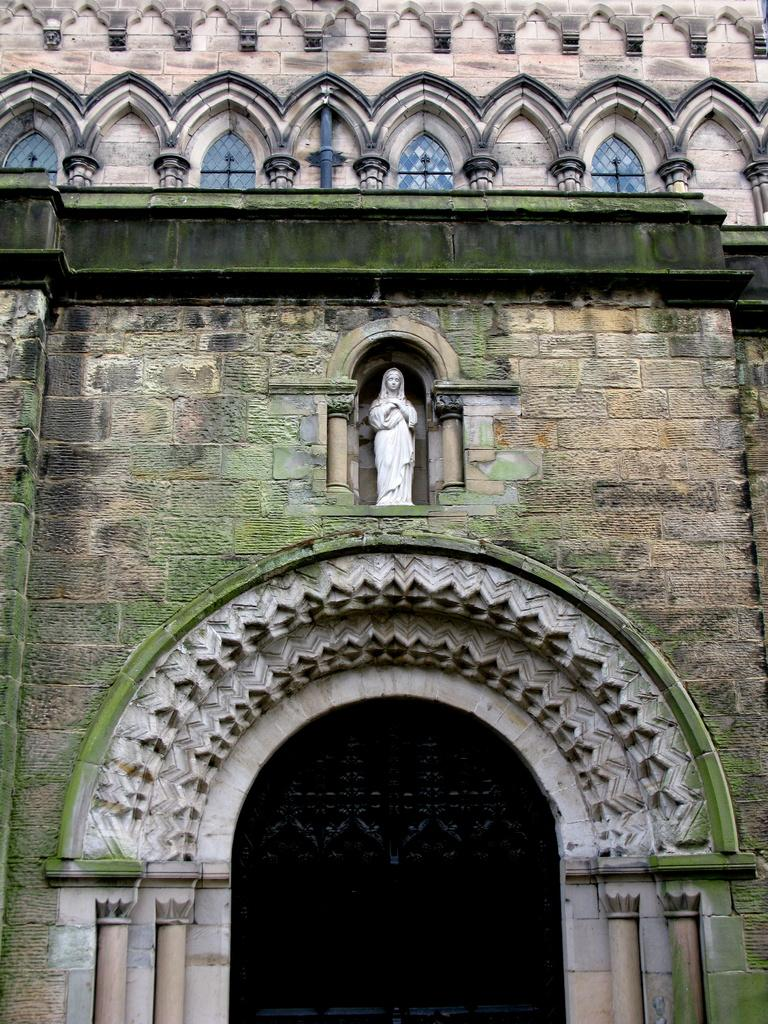What type of structure is in the image? There is a building in the image. What architectural feature can be seen on the building? The building has an arch. Is there any artwork or sculpture on the building? Yes, there is a statue on the building. What type of lighting is present on the building? There are lanterns visible on the building. How far away is the door from the building in the image? There is no door present in the image; the focus is on the building itself and its features. 